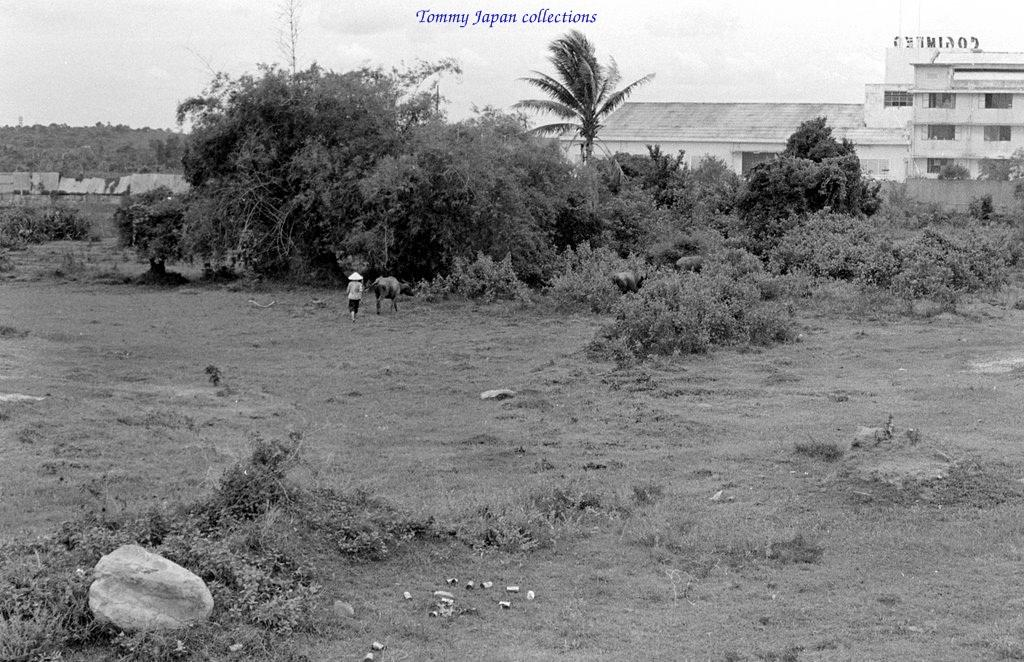What type of vegetation can be seen in the image? There are trees in the image. What type of structures are present in the image? There are buildings in the image. Can you identify any living beings in the image? Yes, there is a person and an animal in the image. What is the ground covered with in the image? There is grass in the image. Can you see the seashore in the image? No, there is no seashore visible in the image. Is the animal in the image a skate? No, the animal in the image is not a skate; it is not mentioned in the provided facts. 